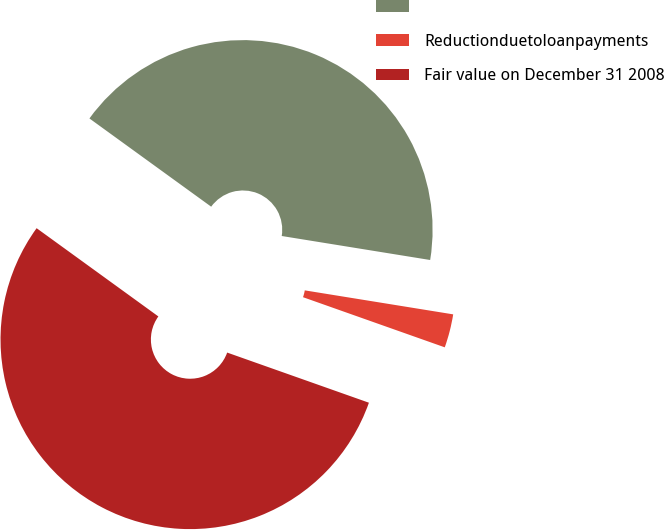<chart> <loc_0><loc_0><loc_500><loc_500><pie_chart><ecel><fcel>Reductionduetoloanpayments<fcel>Fair value on December 31 2008<nl><fcel>42.57%<fcel>2.86%<fcel>54.57%<nl></chart> 